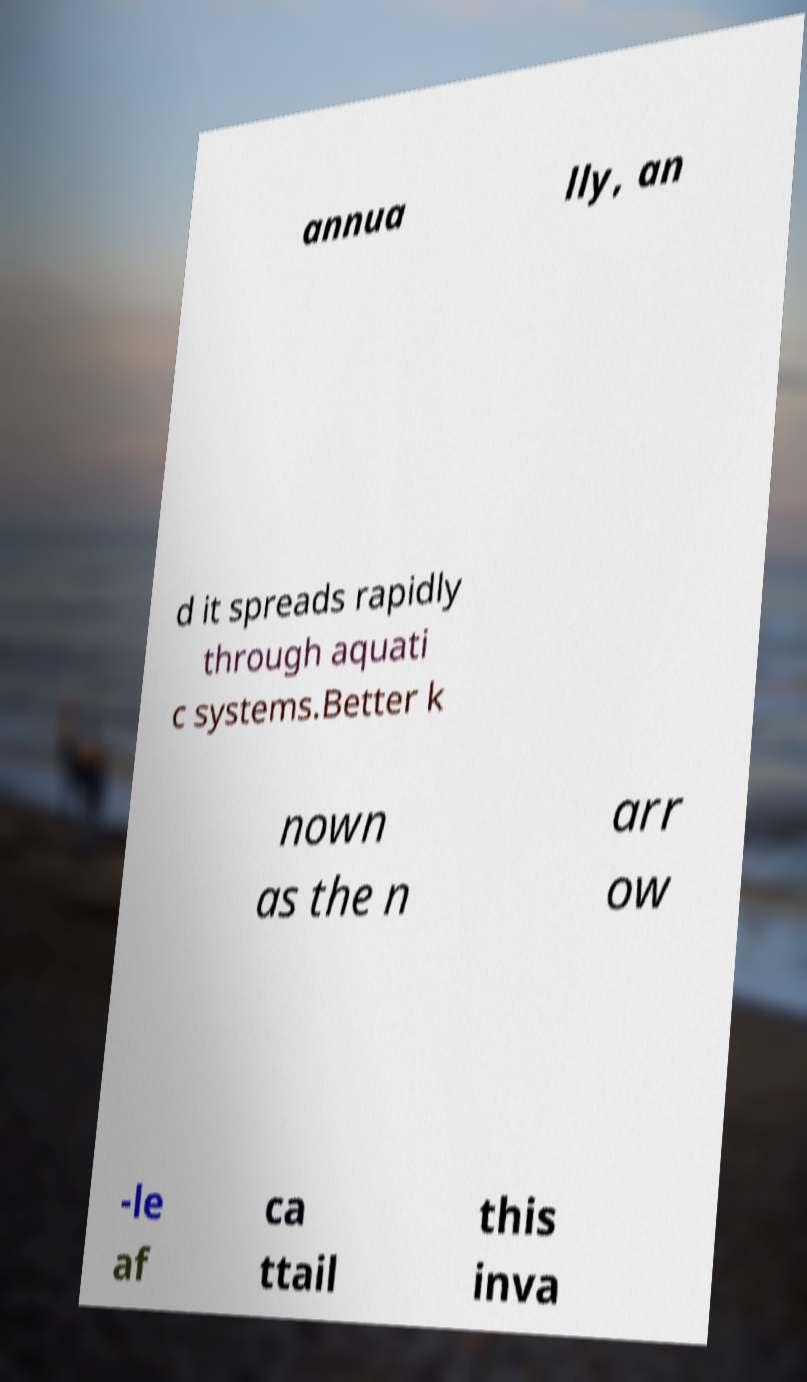There's text embedded in this image that I need extracted. Can you transcribe it verbatim? annua lly, an d it spreads rapidly through aquati c systems.Better k nown as the n arr ow -le af ca ttail this inva 